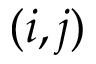Convert formula to latex. <formula><loc_0><loc_0><loc_500><loc_500>( i , j )</formula> 